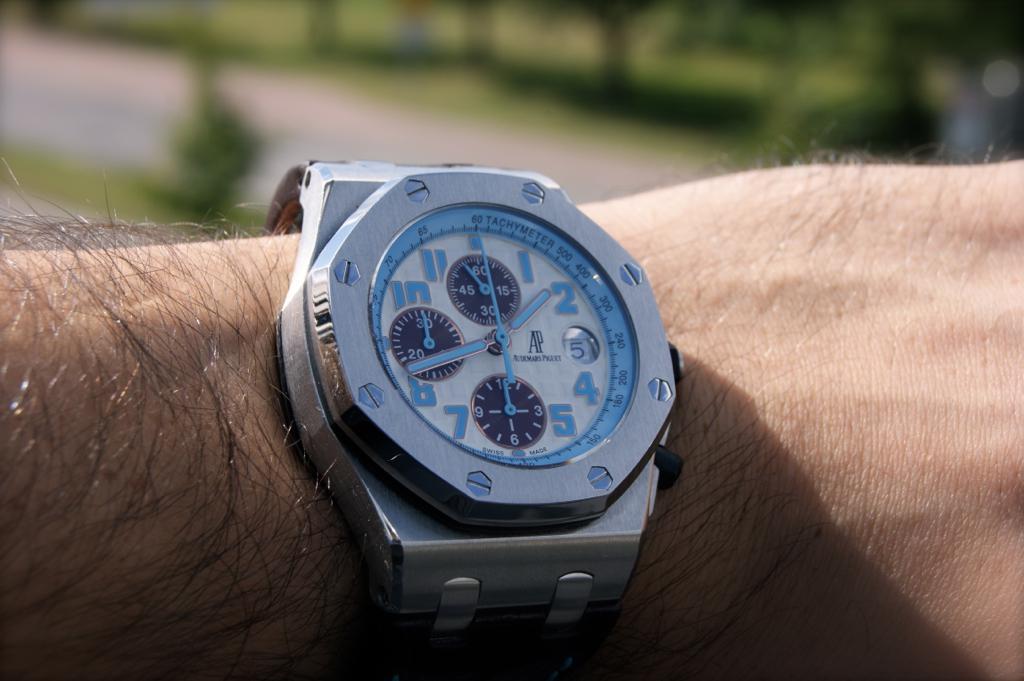What time does the watch show?
Your answer should be compact. 1:43. What number is the small hand pointing too?
Ensure brevity in your answer.  2. 